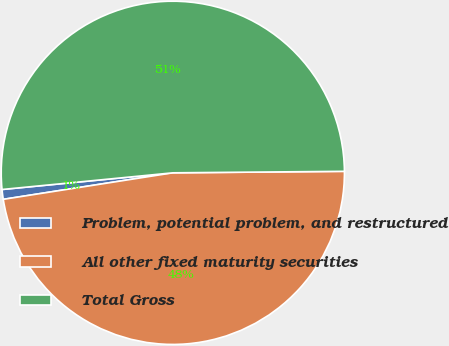Convert chart to OTSL. <chart><loc_0><loc_0><loc_500><loc_500><pie_chart><fcel>Problem, potential problem, and restructured<fcel>All other fixed maturity securities<fcel>Total Gross<nl><fcel>0.92%<fcel>47.67%<fcel>51.41%<nl></chart> 